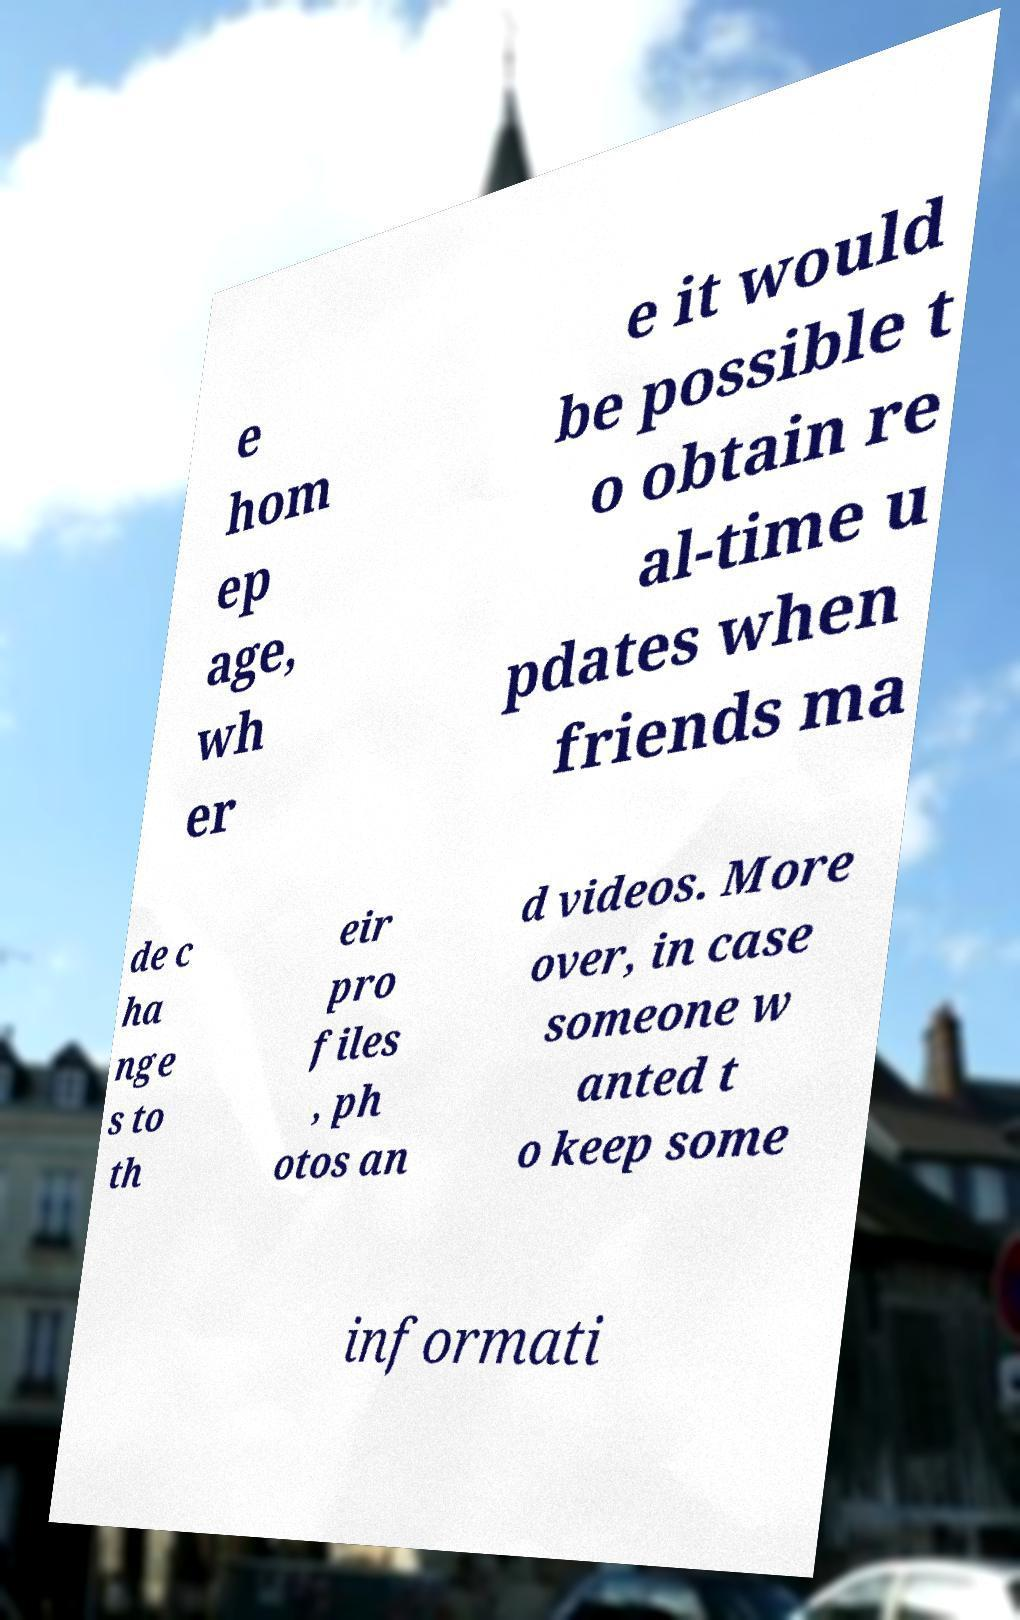Could you assist in decoding the text presented in this image and type it out clearly? e hom ep age, wh er e it would be possible t o obtain re al-time u pdates when friends ma de c ha nge s to th eir pro files , ph otos an d videos. More over, in case someone w anted t o keep some informati 